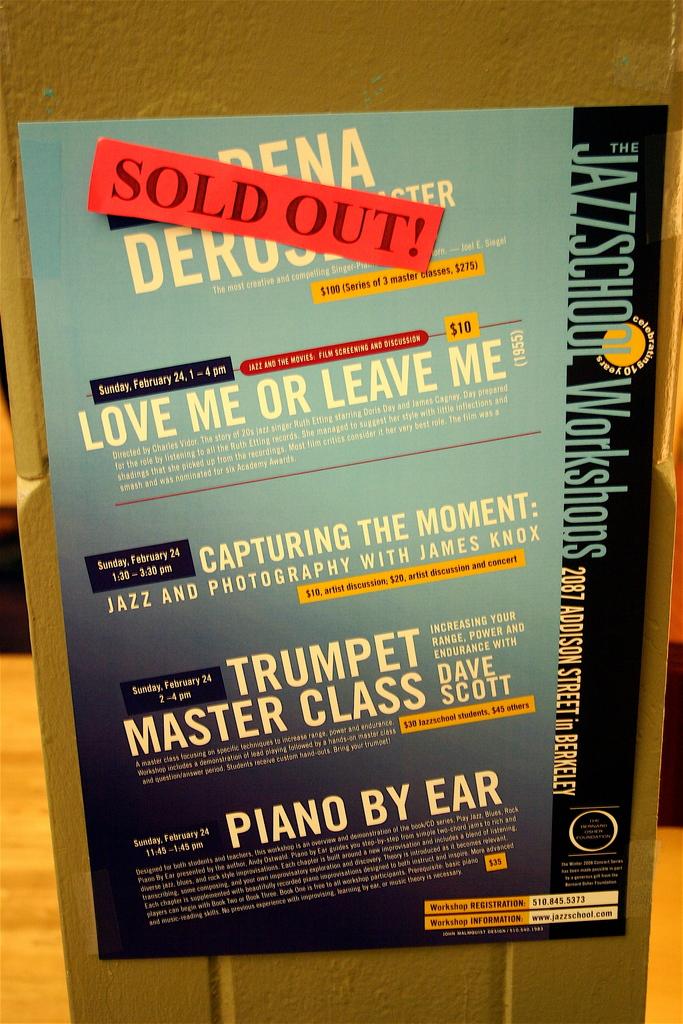Who teaches the trumpet master class?
Ensure brevity in your answer.  Dave scott. Are classes still available?
Your answer should be compact. No. 